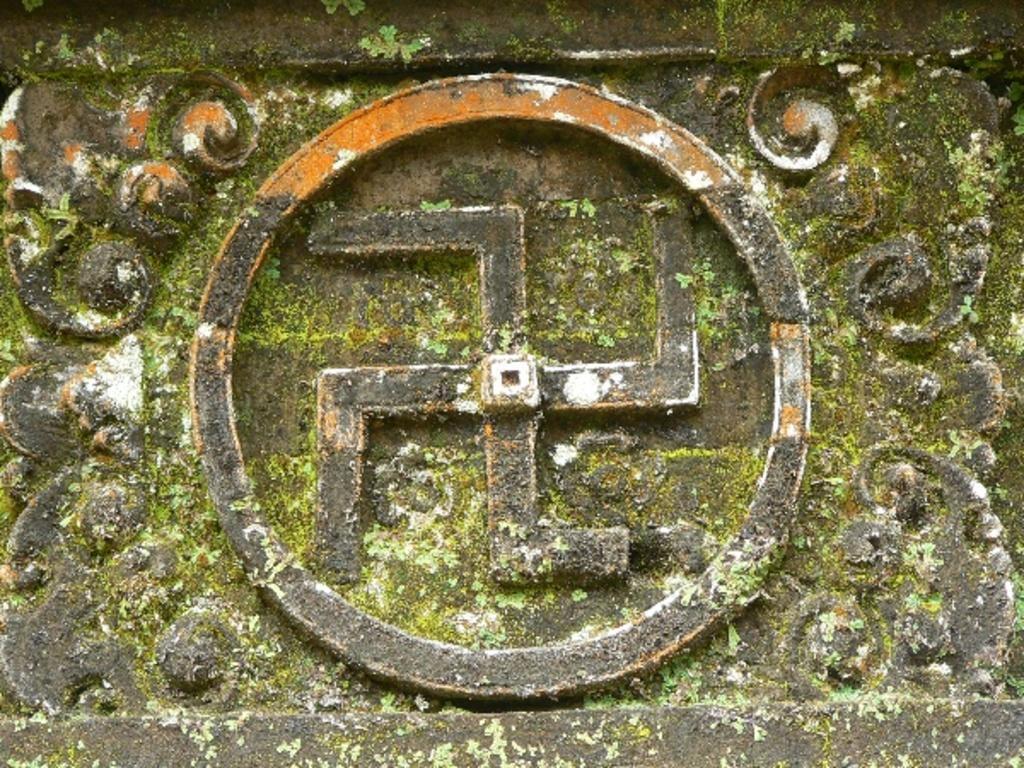Describe this image in one or two sentences. In this picture we can see designs, symbol on a stone plate. 